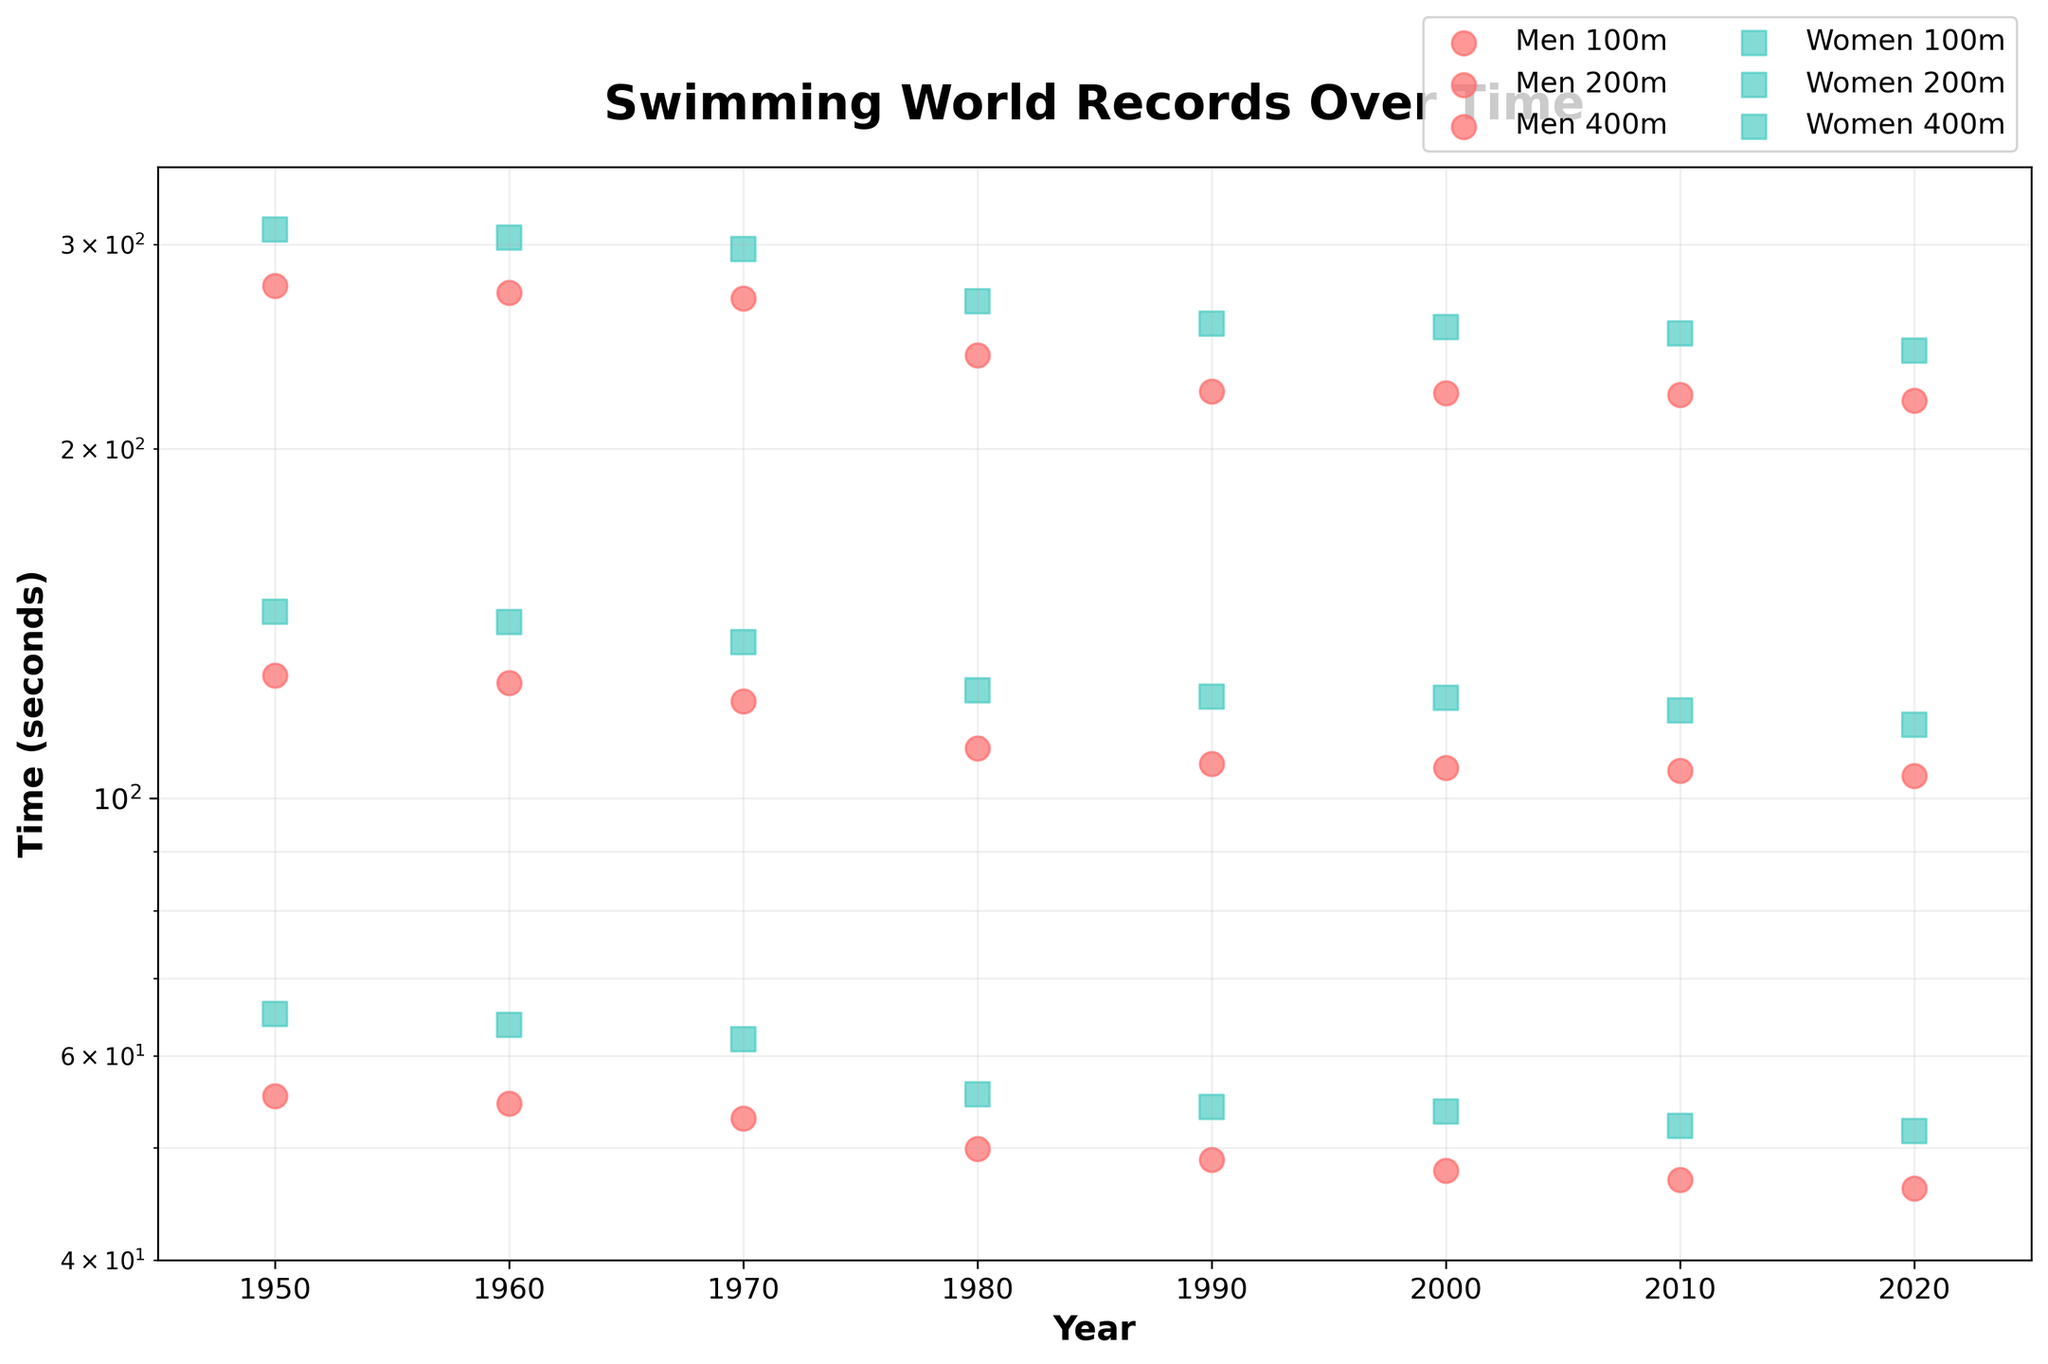What is the title of the plot? The title of the plot is typically displayed at the top of the figure. Here, it states "Swimming World Records Over Time" indicating the content of the plot.
Answer: Swimming World Records Over Time Which axis is on the log scale? The axis on the log scale is indicated by labels showing exponential values or higher ticks towards the lower side of the scale. In this plot, the y-axis shows different swimming times in seconds on a log scale.
Answer: y-axis How many men's and women's world record points are plotted for each distance? To determine the number of points, count the markers for each gender and distance in the plot. There are 8 points for each gender in each distance category: 100m, 200m, and 400m.
Answer: 8 for each distance and gender When did men's 100m world record times drop below 50 seconds? To find this information, observe the plot and locate the intersection of the men's 100m world record times with the 50-second line on the y-axis. It occurs around 1980.
Answer: Around 1980 Which distance shows the greatest improvement in women's world record times from 1950 to 2020? To determine this, compare the starting and ending points for each distance in the women's world records. The largest relative difference can be seen by calculating the difference in times. The 400m distance shows the greatest improvement.
Answer: 400m How do the improvements in men's and women's 200m records compare between 1950 and 2020? Observe and compare the overall trend and reduction in times for both genders over the years. Men's records improved from around 127.6s to 104.6s, while women's records improved from around 144.8s to 115.7s. Compare the total reduction for each gender.
Answer: Both show significant improvement, with men reducing approximately 23s and women reducing approximately 29s Is the improvement trend more linear or exponential over time? Examine the scatter of the points and the general shape of the trend lines over the log scale. Linear trends would show more evenly spaced improvements, while exponential trends would show larger drops followed by smaller drops. Both show trends that become smaller as you move forward in time, which indicates an exponential trend.
Answer: Exponential What is the primary visual difference between men's and women's world record markers? Look at the visual representation of the markers. Men's records are displayed with one color and marker style, while women's records use a different combination. Men's markers are red circles, and women's markers are teal squares.
Answer: Color and marker style In which decade did women's 400m world record time drop most significantly? Identify the points for women's 400m records and look for the largest vertical drop between two consecutive decades. The greatest drop occurs between 1970 and 1980.
Answer: 1970 to 1980 Which gender shows a more consistent improvement over the years across all distances? Analyze the overall trend for both genders by observing the straightness and steadiness of the scatter points' decline. Men's records appear to display a smoother, more consistent improvement trend compared to women's.
Answer: Men 